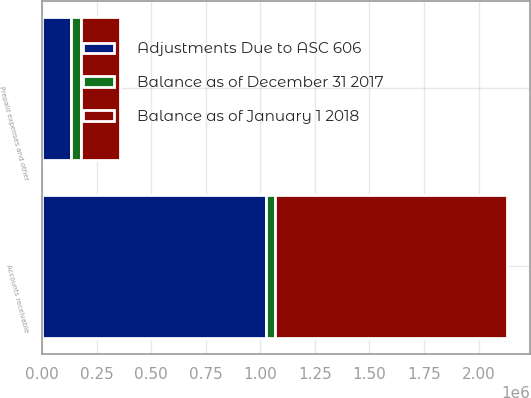Convert chart. <chart><loc_0><loc_0><loc_500><loc_500><stacked_bar_chart><ecel><fcel>Accounts receivable<fcel>Prepaid expenses and other<nl><fcel>Adjustments Due to ASC 606<fcel>1.02711e+06<fcel>134479<nl><fcel>Balance as of December 31 2017<fcel>38511<fcel>44508<nl><fcel>Balance as of January 1 2018<fcel>1.06562e+06<fcel>178987<nl></chart> 